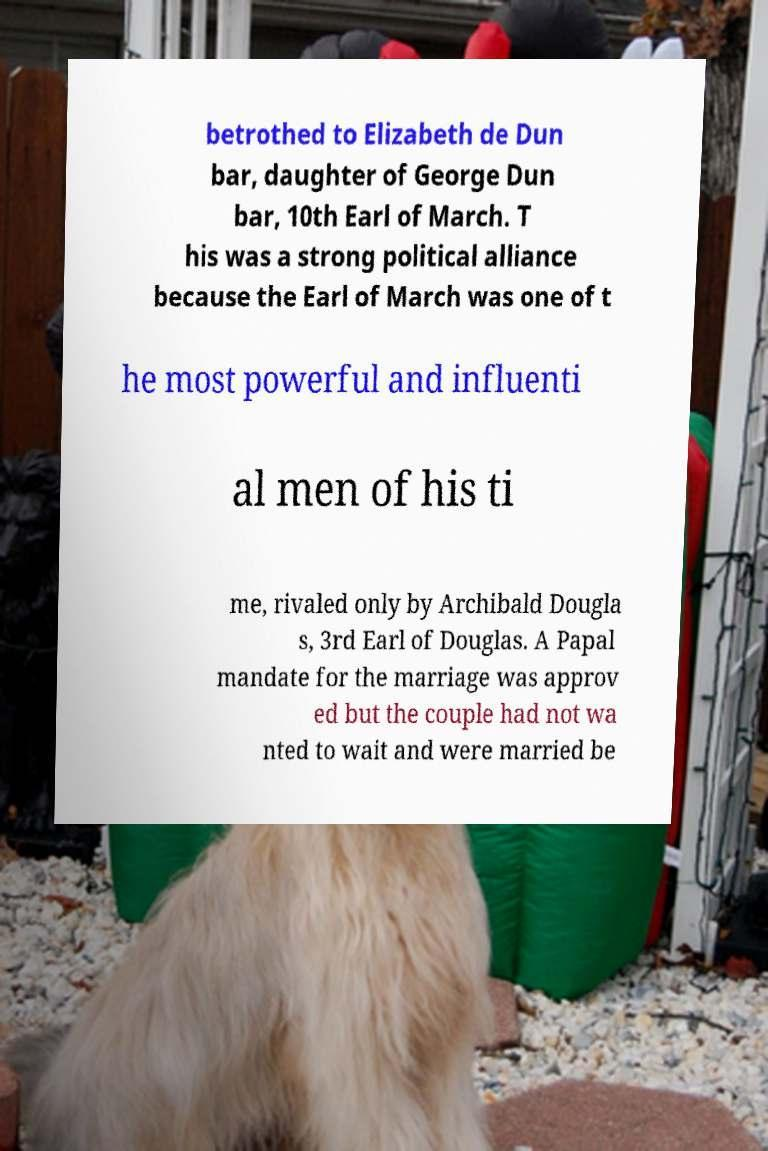What messages or text are displayed in this image? I need them in a readable, typed format. betrothed to Elizabeth de Dun bar, daughter of George Dun bar, 10th Earl of March. T his was a strong political alliance because the Earl of March was one of t he most powerful and influenti al men of his ti me, rivaled only by Archibald Dougla s, 3rd Earl of Douglas. A Papal mandate for the marriage was approv ed but the couple had not wa nted to wait and were married be 